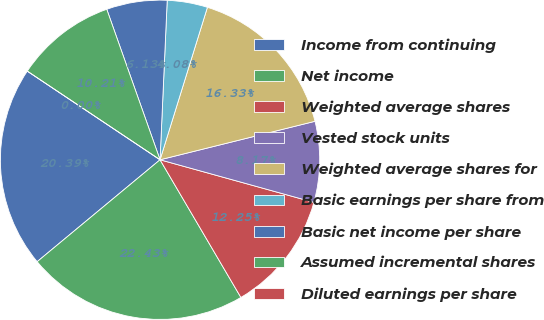Convert chart to OTSL. <chart><loc_0><loc_0><loc_500><loc_500><pie_chart><fcel>Income from continuing<fcel>Net income<fcel>Weighted average shares<fcel>Vested stock units<fcel>Weighted average shares for<fcel>Basic earnings per share from<fcel>Basic net income per share<fcel>Assumed incremental shares<fcel>Diluted earnings per share<nl><fcel>20.39%<fcel>22.43%<fcel>12.25%<fcel>8.17%<fcel>16.33%<fcel>4.08%<fcel>6.13%<fcel>10.21%<fcel>0.0%<nl></chart> 